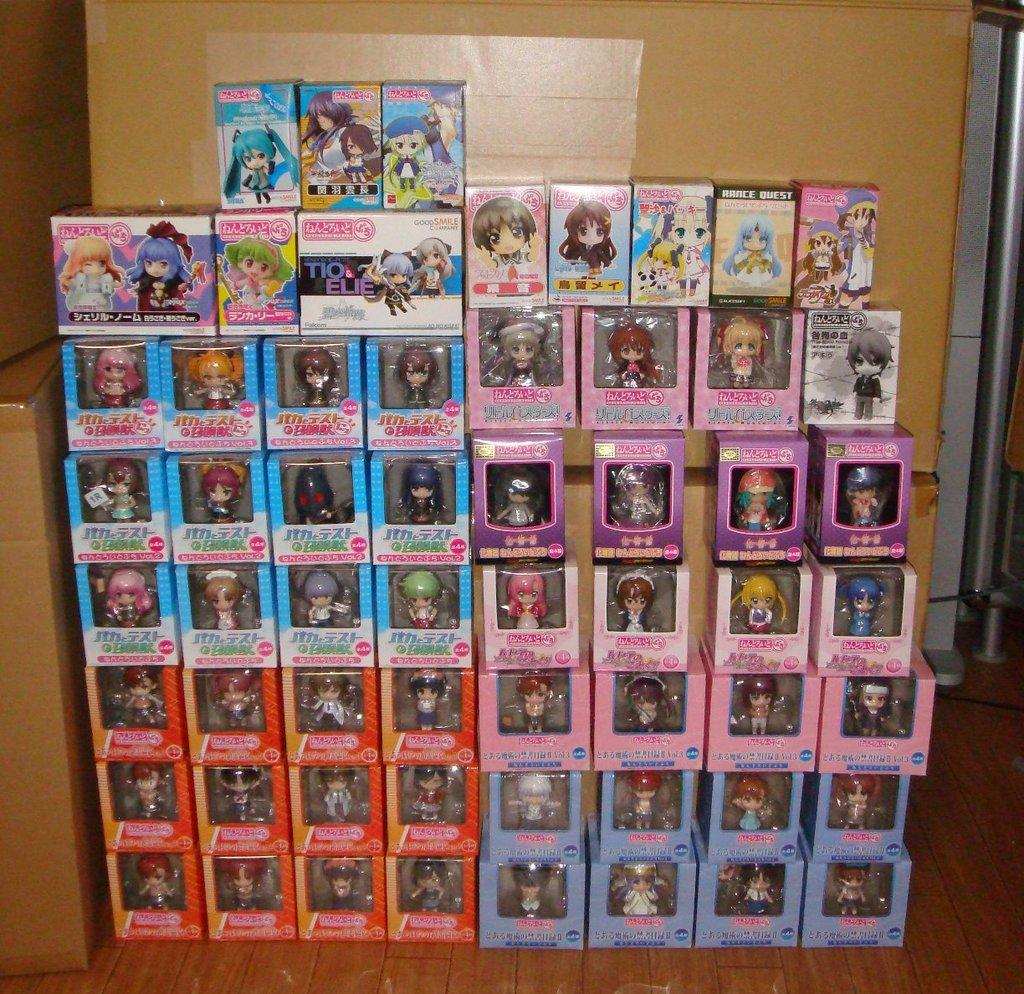What types of objects are present in the image? The image contains various boxes. What are the contents of the boxes? The boxes contain different toys. Can you describe the arrangement of the boxes in the image? There are boxes in the background of the image and on the left side of the image. What is the rate of the stage in the image? There is no stage present in the image, so it is not possible to determine a rate. 